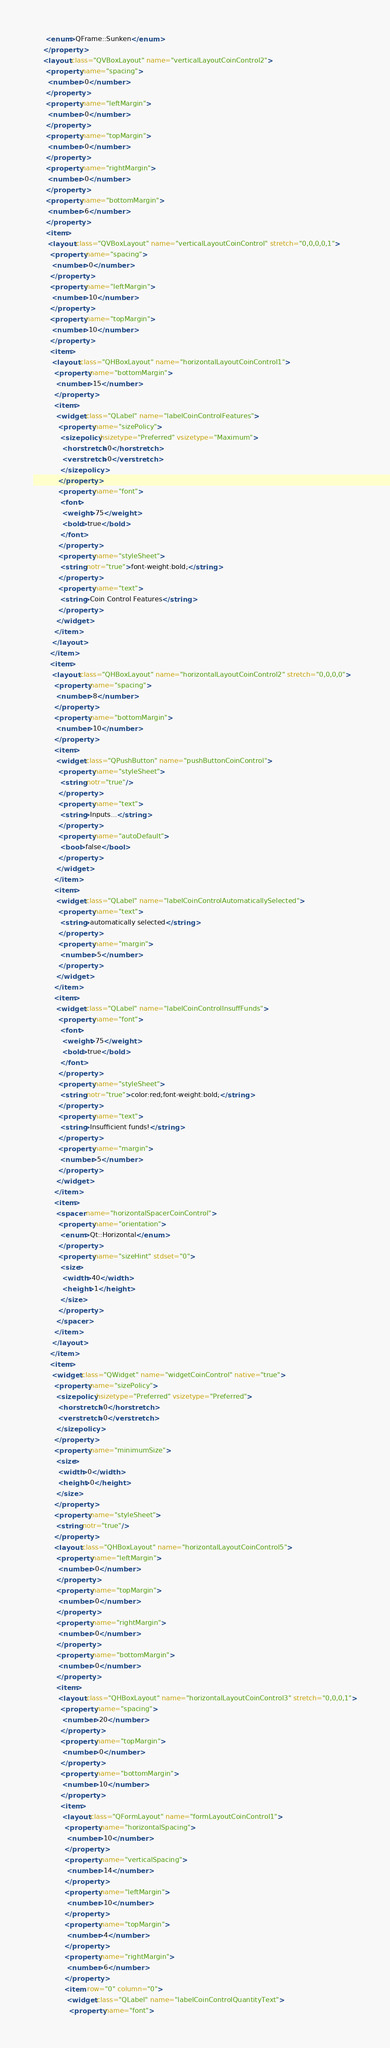<code> <loc_0><loc_0><loc_500><loc_500><_XML_>      <enum>QFrame::Sunken</enum>
     </property>
     <layout class="QVBoxLayout" name="verticalLayoutCoinControl2">
      <property name="spacing">
       <number>0</number>
      </property>
      <property name="leftMargin">
       <number>0</number>
      </property>
      <property name="topMargin">
       <number>0</number>
      </property>
      <property name="rightMargin">
       <number>0</number>
      </property>
      <property name="bottomMargin">
       <number>6</number>
      </property>
      <item>
       <layout class="QVBoxLayout" name="verticalLayoutCoinControl" stretch="0,0,0,0,1">
        <property name="spacing">
         <number>0</number>
        </property>
        <property name="leftMargin">
         <number>10</number>
        </property>
        <property name="topMargin">
         <number>10</number>
        </property>
        <item>
         <layout class="QHBoxLayout" name="horizontalLayoutCoinControl1">
          <property name="bottomMargin">
           <number>15</number>
          </property>
          <item>
           <widget class="QLabel" name="labelCoinControlFeatures">
            <property name="sizePolicy">
             <sizepolicy hsizetype="Preferred" vsizetype="Maximum">
              <horstretch>0</horstretch>
              <verstretch>0</verstretch>
             </sizepolicy>
            </property>
            <property name="font">
             <font>
              <weight>75</weight>
              <bold>true</bold>
             </font>
            </property>
            <property name="styleSheet">
             <string notr="true">font-weight:bold;</string>
            </property>
            <property name="text">
             <string>Coin Control Features</string>
            </property>
           </widget>
          </item>
         </layout>
        </item>
        <item>
         <layout class="QHBoxLayout" name="horizontalLayoutCoinControl2" stretch="0,0,0,0">
          <property name="spacing">
           <number>8</number>
          </property>
          <property name="bottomMargin">
           <number>10</number>
          </property>
          <item>
           <widget class="QPushButton" name="pushButtonCoinControl">
            <property name="styleSheet">
             <string notr="true"/>
            </property>
            <property name="text">
             <string>Inputs...</string>
            </property>
            <property name="autoDefault">
             <bool>false</bool>
            </property>
           </widget>
          </item>
          <item>
           <widget class="QLabel" name="labelCoinControlAutomaticallySelected">
            <property name="text">
             <string>automatically selected</string>
            </property>
            <property name="margin">
             <number>5</number>
            </property>
           </widget>
          </item>
          <item>
           <widget class="QLabel" name="labelCoinControlInsuffFunds">
            <property name="font">
             <font>
              <weight>75</weight>
              <bold>true</bold>
             </font>
            </property>
            <property name="styleSheet">
             <string notr="true">color:red;font-weight:bold;</string>
            </property>
            <property name="text">
             <string>Insufficient funds!</string>
            </property>
            <property name="margin">
             <number>5</number>
            </property>
           </widget>
          </item>
          <item>
           <spacer name="horizontalSpacerCoinControl">
            <property name="orientation">
             <enum>Qt::Horizontal</enum>
            </property>
            <property name="sizeHint" stdset="0">
             <size>
              <width>40</width>
              <height>1</height>
             </size>
            </property>
           </spacer>
          </item>
         </layout>
        </item>
        <item>
         <widget class="QWidget" name="widgetCoinControl" native="true">
          <property name="sizePolicy">
           <sizepolicy hsizetype="Preferred" vsizetype="Preferred">
            <horstretch>0</horstretch>
            <verstretch>0</verstretch>
           </sizepolicy>
          </property>
          <property name="minimumSize">
           <size>
            <width>0</width>
            <height>0</height>
           </size>
          </property>
          <property name="styleSheet">
           <string notr="true"/>
          </property>
          <layout class="QHBoxLayout" name="horizontalLayoutCoinControl5">
           <property name="leftMargin">
            <number>0</number>
           </property>
           <property name="topMargin">
            <number>0</number>
           </property>
           <property name="rightMargin">
            <number>0</number>
           </property>
           <property name="bottomMargin">
            <number>0</number>
           </property>
           <item>
            <layout class="QHBoxLayout" name="horizontalLayoutCoinControl3" stretch="0,0,0,1">
             <property name="spacing">
              <number>20</number>
             </property>
             <property name="topMargin">
              <number>0</number>
             </property>
             <property name="bottomMargin">
              <number>10</number>
             </property>
             <item>
              <layout class="QFormLayout" name="formLayoutCoinControl1">
               <property name="horizontalSpacing">
                <number>10</number>
               </property>
               <property name="verticalSpacing">
                <number>14</number>
               </property>
               <property name="leftMargin">
                <number>10</number>
               </property>
               <property name="topMargin">
                <number>4</number>
               </property>
               <property name="rightMargin">
                <number>6</number>
               </property>
               <item row="0" column="0">
                <widget class="QLabel" name="labelCoinControlQuantityText">
                 <property name="font"></code> 